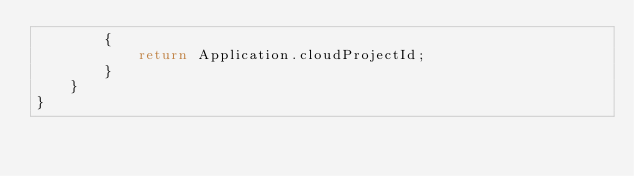<code> <loc_0><loc_0><loc_500><loc_500><_C#_>        {
            return Application.cloudProjectId;
        }
    }
}
</code> 